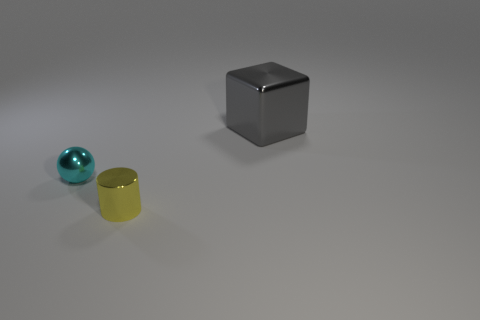Add 2 big metal cylinders. How many objects exist? 5 Subtract all cubes. How many objects are left? 2 Add 1 objects. How many objects are left? 4 Add 2 tiny cylinders. How many tiny cylinders exist? 3 Subtract 0 green cylinders. How many objects are left? 3 Subtract all small gray cylinders. Subtract all big gray metallic objects. How many objects are left? 2 